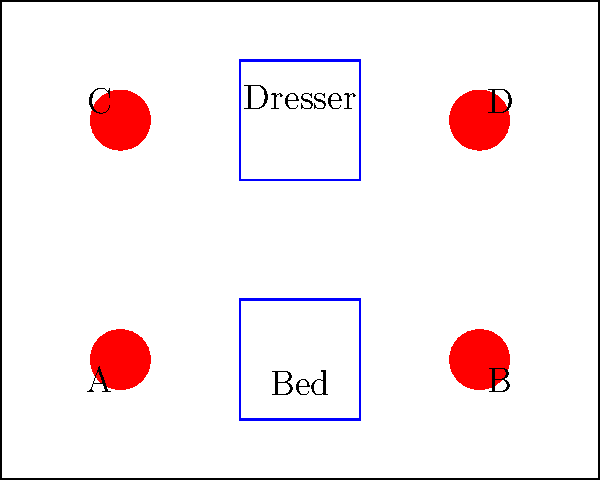In a room measuring 10 meters by 8 meters, four heat treatment units (A, B, C, and D) are placed in the corners for bed bug control. The room contains a bed and a dresser as shown. If each heat unit has an effective range of 5 meters, what is the minimum number of units needed to ensure complete coverage of the room? To solve this problem, we need to follow these steps:

1. Understand the room dimensions: 10m x 8m
2. Identify the positions of the heat units:
   A: (2,2), B: (8,2), C: (2,6), D: (8,6)
3. Note that each unit has an effective range of 5 meters
4. Calculate the coverage area of each unit:
   - The coverage area of each unit is a circle with a radius of 5 meters
   - Area of coverage = $\pi r^2 = \pi (5^2) \approx 78.54 \text{ m}^2$
5. Compare the total room area with the coverage area of a single unit:
   - Room area = 10m x 8m = 80 $\text{m}^2$
   - One unit's coverage (78.54 $\text{m}^2$) is slightly less than the room area
6. Consider the room's shape and furniture placement:
   - The room is rectangular, not circular
   - There are furniture items that may obstruct heat flow
7. Analyze the coverage with different numbers of units:
   - Using only one unit would leave corners uncovered
   - Using two units diagonally (e.g., A and D) would cover most of the room but might leave some areas behind furniture under-treated
   - Using three units would likely cover the entire room, but to ensure complete coverage, especially considering furniture obstacles, all four units are ideal

Therefore, to ensure complete coverage of the room, including areas that might be partially obstructed by furniture, all four heat treatment units are needed.
Answer: 4 units 